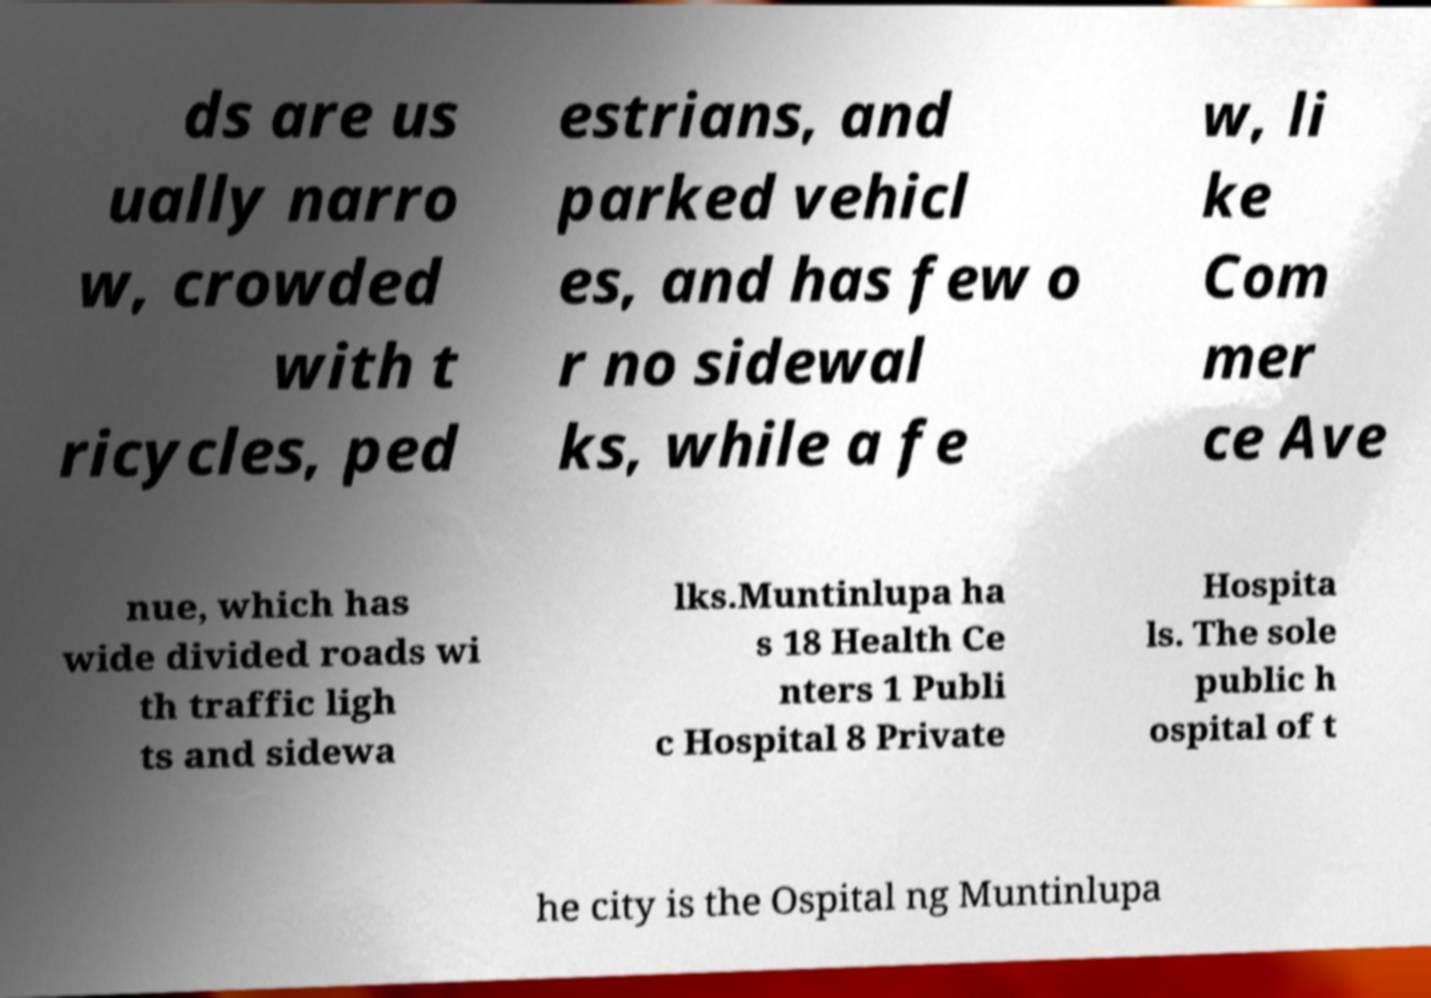Please identify and transcribe the text found in this image. ds are us ually narro w, crowded with t ricycles, ped estrians, and parked vehicl es, and has few o r no sidewal ks, while a fe w, li ke Com mer ce Ave nue, which has wide divided roads wi th traffic ligh ts and sidewa lks.Muntinlupa ha s 18 Health Ce nters 1 Publi c Hospital 8 Private Hospita ls. The sole public h ospital of t he city is the Ospital ng Muntinlupa 